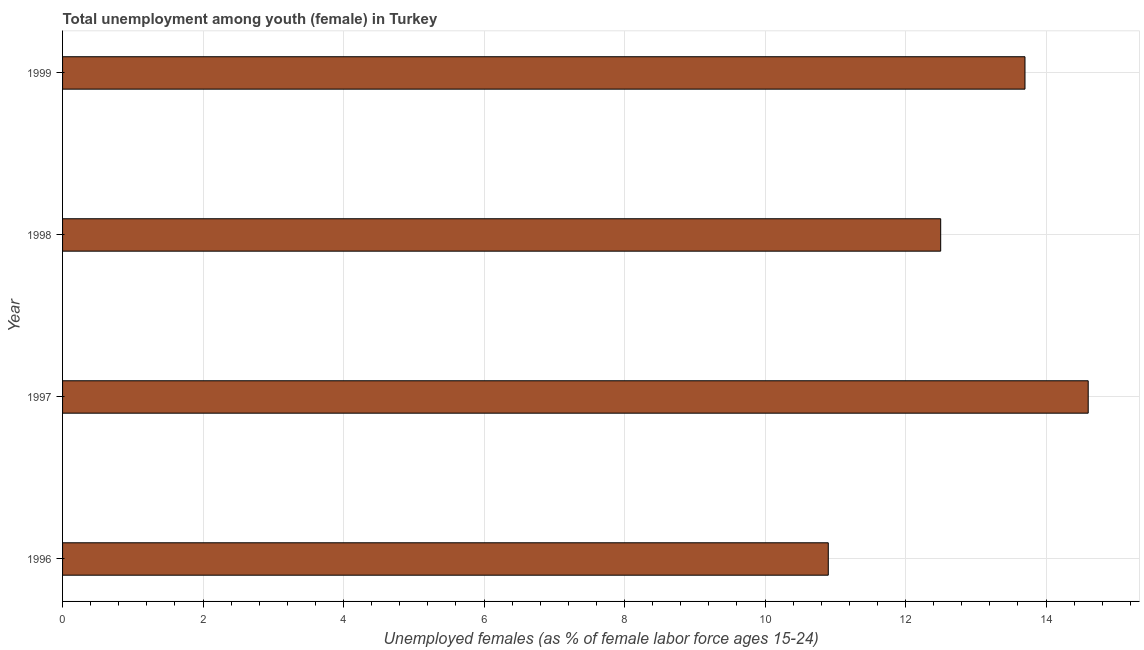Does the graph contain grids?
Your response must be concise. Yes. What is the title of the graph?
Give a very brief answer. Total unemployment among youth (female) in Turkey. What is the label or title of the X-axis?
Your answer should be compact. Unemployed females (as % of female labor force ages 15-24). What is the unemployed female youth population in 1996?
Ensure brevity in your answer.  10.9. Across all years, what is the maximum unemployed female youth population?
Provide a short and direct response. 14.6. Across all years, what is the minimum unemployed female youth population?
Your answer should be very brief. 10.9. What is the sum of the unemployed female youth population?
Your response must be concise. 51.7. What is the average unemployed female youth population per year?
Ensure brevity in your answer.  12.93. What is the median unemployed female youth population?
Give a very brief answer. 13.1. In how many years, is the unemployed female youth population greater than 2.8 %?
Keep it short and to the point. 4. Do a majority of the years between 1999 and 1997 (inclusive) have unemployed female youth population greater than 9.2 %?
Provide a succinct answer. Yes. What is the ratio of the unemployed female youth population in 1996 to that in 1997?
Offer a very short reply. 0.75. Is the sum of the unemployed female youth population in 1996 and 1998 greater than the maximum unemployed female youth population across all years?
Keep it short and to the point. Yes. What is the difference between two consecutive major ticks on the X-axis?
Your answer should be very brief. 2. Are the values on the major ticks of X-axis written in scientific E-notation?
Ensure brevity in your answer.  No. What is the Unemployed females (as % of female labor force ages 15-24) in 1996?
Provide a succinct answer. 10.9. What is the Unemployed females (as % of female labor force ages 15-24) of 1997?
Your answer should be compact. 14.6. What is the Unemployed females (as % of female labor force ages 15-24) in 1998?
Provide a short and direct response. 12.5. What is the Unemployed females (as % of female labor force ages 15-24) in 1999?
Your answer should be compact. 13.7. What is the difference between the Unemployed females (as % of female labor force ages 15-24) in 1996 and 1997?
Give a very brief answer. -3.7. What is the difference between the Unemployed females (as % of female labor force ages 15-24) in 1996 and 1998?
Give a very brief answer. -1.6. What is the difference between the Unemployed females (as % of female labor force ages 15-24) in 1997 and 1998?
Keep it short and to the point. 2.1. What is the difference between the Unemployed females (as % of female labor force ages 15-24) in 1997 and 1999?
Your answer should be compact. 0.9. What is the difference between the Unemployed females (as % of female labor force ages 15-24) in 1998 and 1999?
Your answer should be very brief. -1.2. What is the ratio of the Unemployed females (as % of female labor force ages 15-24) in 1996 to that in 1997?
Your answer should be compact. 0.75. What is the ratio of the Unemployed females (as % of female labor force ages 15-24) in 1996 to that in 1998?
Ensure brevity in your answer.  0.87. What is the ratio of the Unemployed females (as % of female labor force ages 15-24) in 1996 to that in 1999?
Your answer should be compact. 0.8. What is the ratio of the Unemployed females (as % of female labor force ages 15-24) in 1997 to that in 1998?
Provide a succinct answer. 1.17. What is the ratio of the Unemployed females (as % of female labor force ages 15-24) in 1997 to that in 1999?
Provide a short and direct response. 1.07. What is the ratio of the Unemployed females (as % of female labor force ages 15-24) in 1998 to that in 1999?
Ensure brevity in your answer.  0.91. 